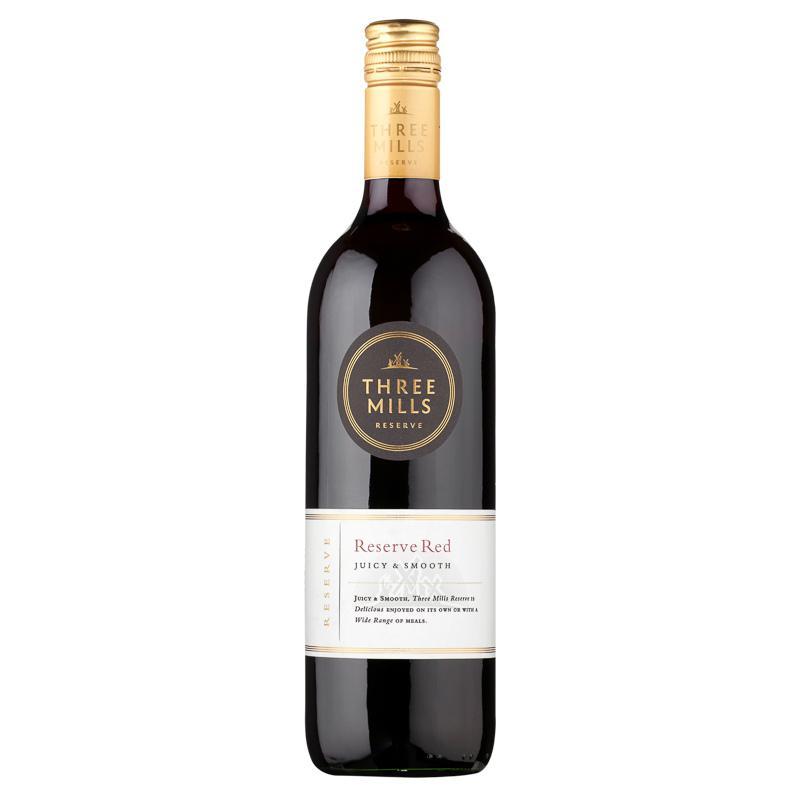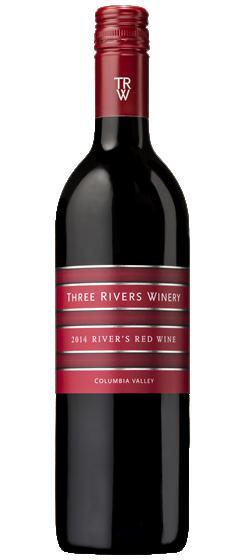The first image is the image on the left, the second image is the image on the right. For the images displayed, is the sentence "An image includes at least one bottle with a burgundy colored label and wrap over the cap." factually correct? Answer yes or no. Yes. The first image is the image on the left, the second image is the image on the right. Considering the images on both sides, is "Three wine glasses are lined up in the image on the left." valid? Answer yes or no. No. 